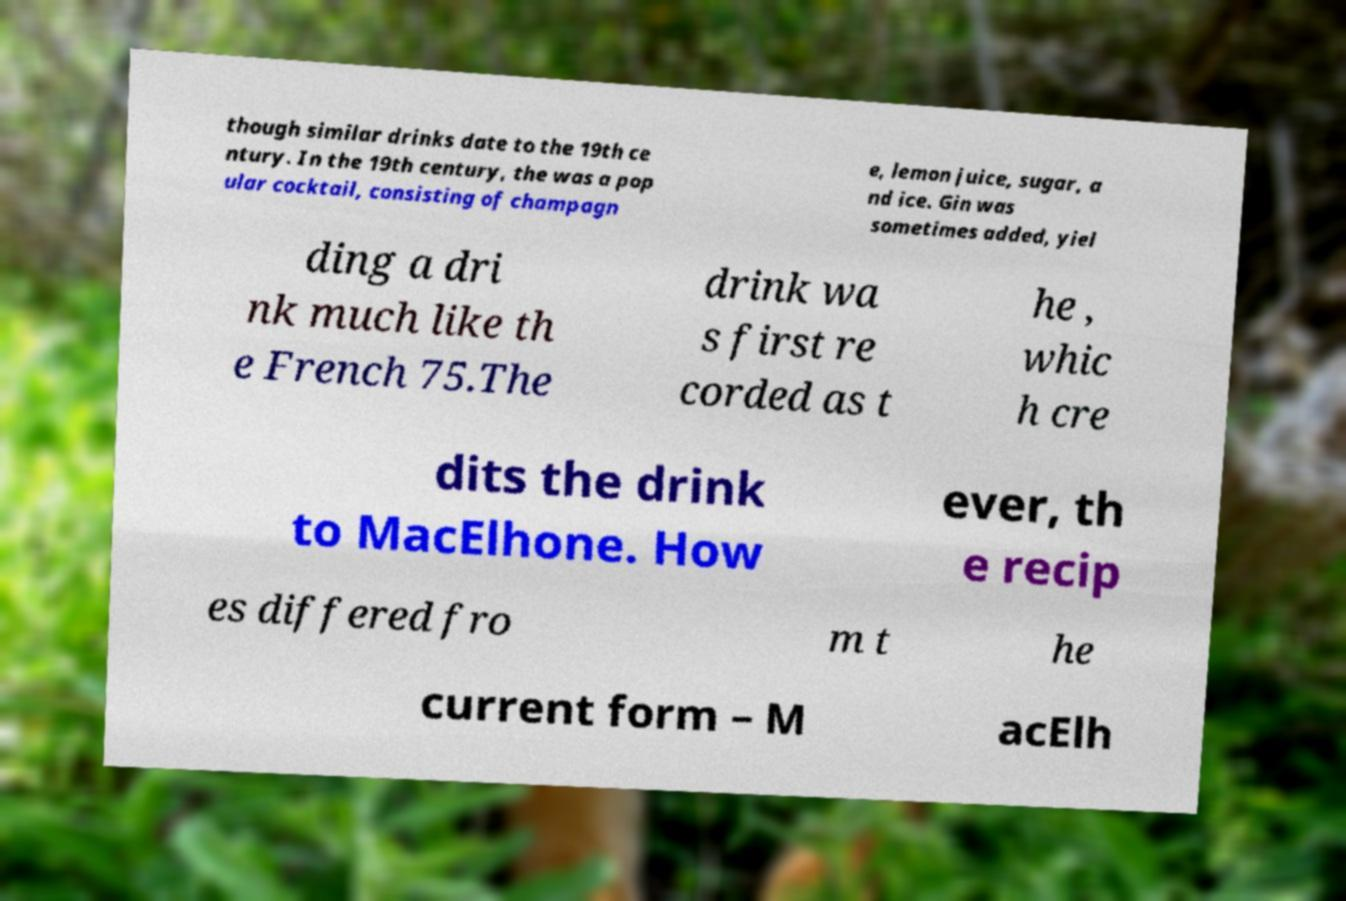Could you extract and type out the text from this image? though similar drinks date to the 19th ce ntury. In the 19th century, the was a pop ular cocktail, consisting of champagn e, lemon juice, sugar, a nd ice. Gin was sometimes added, yiel ding a dri nk much like th e French 75.The drink wa s first re corded as t he , whic h cre dits the drink to MacElhone. How ever, th e recip es differed fro m t he current form – M acElh 